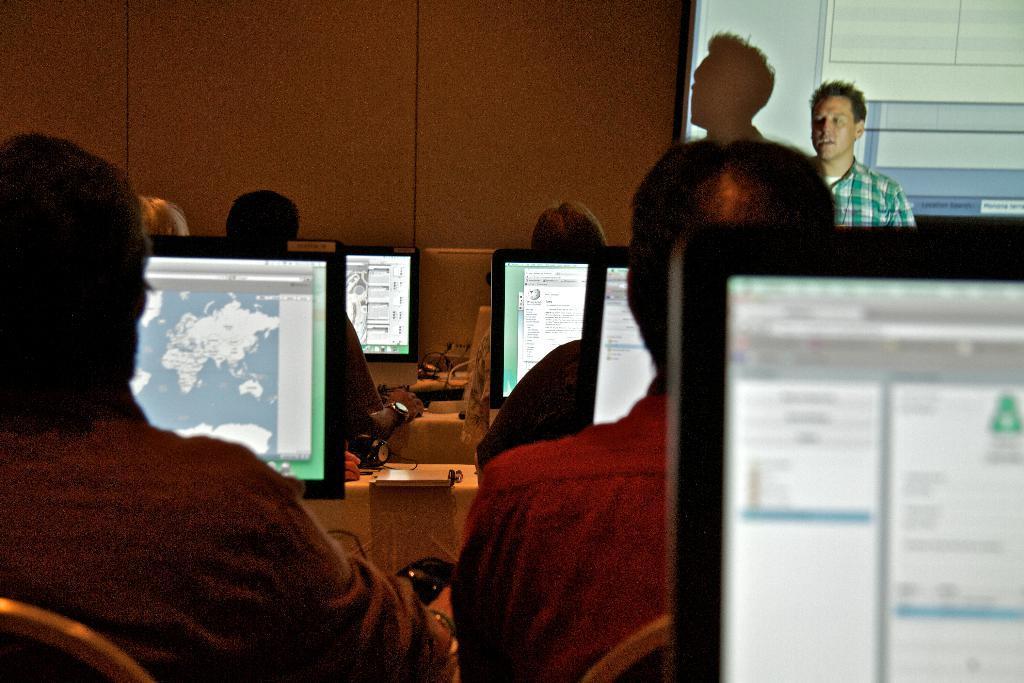Please provide a concise description of this image. In this image we can see some people are sitting in front of the computers and in the background, we can see a person standing and talking. There is a wall and we can see a projector screen. 